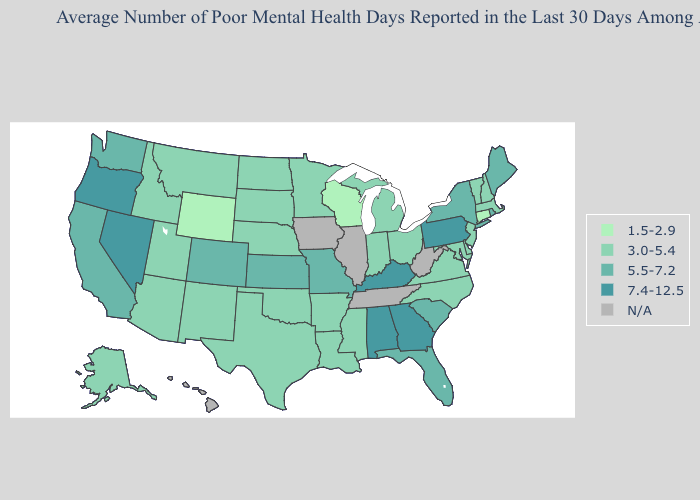How many symbols are there in the legend?
Be succinct. 5. What is the highest value in states that border Alabama?
Write a very short answer. 7.4-12.5. Name the states that have a value in the range N/A?
Be succinct. Hawaii, Illinois, Iowa, Tennessee, West Virginia. Among the states that border New Jersey , does New York have the highest value?
Give a very brief answer. No. Name the states that have a value in the range N/A?
Write a very short answer. Hawaii, Illinois, Iowa, Tennessee, West Virginia. Name the states that have a value in the range 3.0-5.4?
Short answer required. Alaska, Arizona, Arkansas, Delaware, Idaho, Indiana, Louisiana, Maryland, Massachusetts, Michigan, Minnesota, Mississippi, Montana, Nebraska, New Hampshire, New Jersey, New Mexico, North Carolina, North Dakota, Ohio, Oklahoma, South Dakota, Texas, Utah, Vermont, Virginia. What is the lowest value in the Northeast?
Answer briefly. 1.5-2.9. Which states hav the highest value in the South?
Be succinct. Alabama, Georgia, Kentucky. Name the states that have a value in the range N/A?
Concise answer only. Hawaii, Illinois, Iowa, Tennessee, West Virginia. Name the states that have a value in the range N/A?
Give a very brief answer. Hawaii, Illinois, Iowa, Tennessee, West Virginia. Among the states that border New Mexico , does Utah have the highest value?
Concise answer only. No. Does the first symbol in the legend represent the smallest category?
Write a very short answer. Yes. Which states have the highest value in the USA?
Keep it brief. Alabama, Georgia, Kentucky, Nevada, Oregon, Pennsylvania. What is the lowest value in the West?
Answer briefly. 1.5-2.9. What is the value of Pennsylvania?
Quick response, please. 7.4-12.5. 